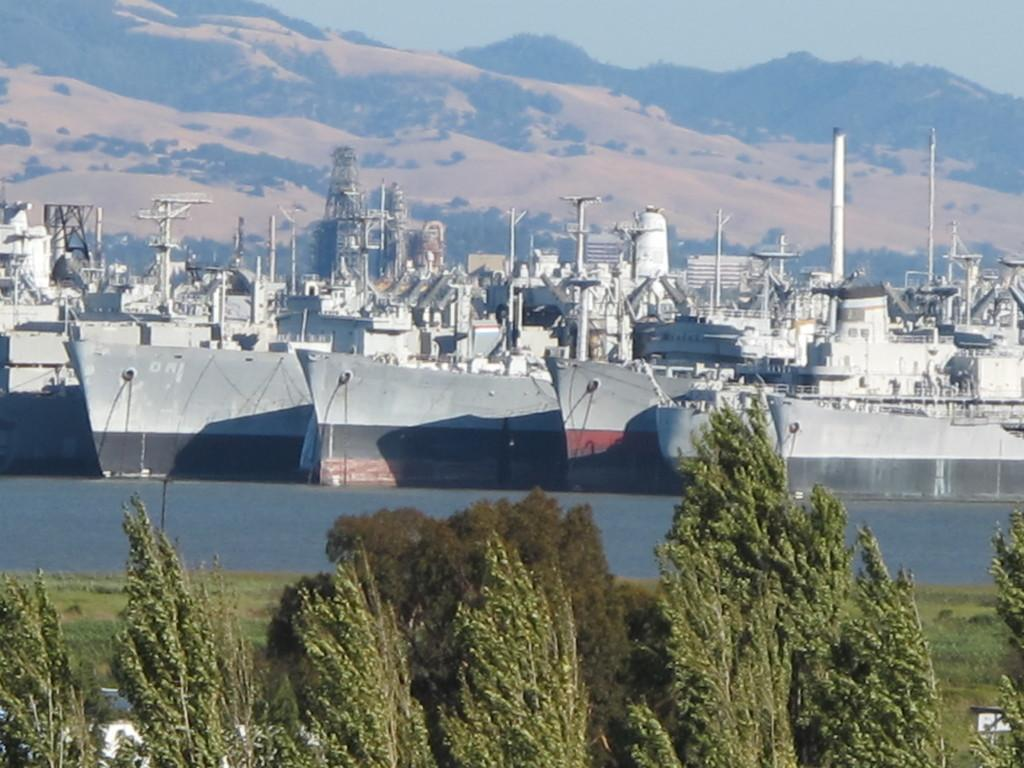What type of vegetation can be seen in the image? There is grass in the image. What is located in the front of the image? There are trees in the front of the image. What can be seen in the background of the image? There is water and the sky visible in the background of the image. What is floating on the water in the image? There are ships in the water. What type of spoon is being used to stir the substance in the image? There is no spoon or substance present in the image. What system is responsible for the movement of the trees in the image? The trees in the image are stationary, and there is no system responsible for their movement. 